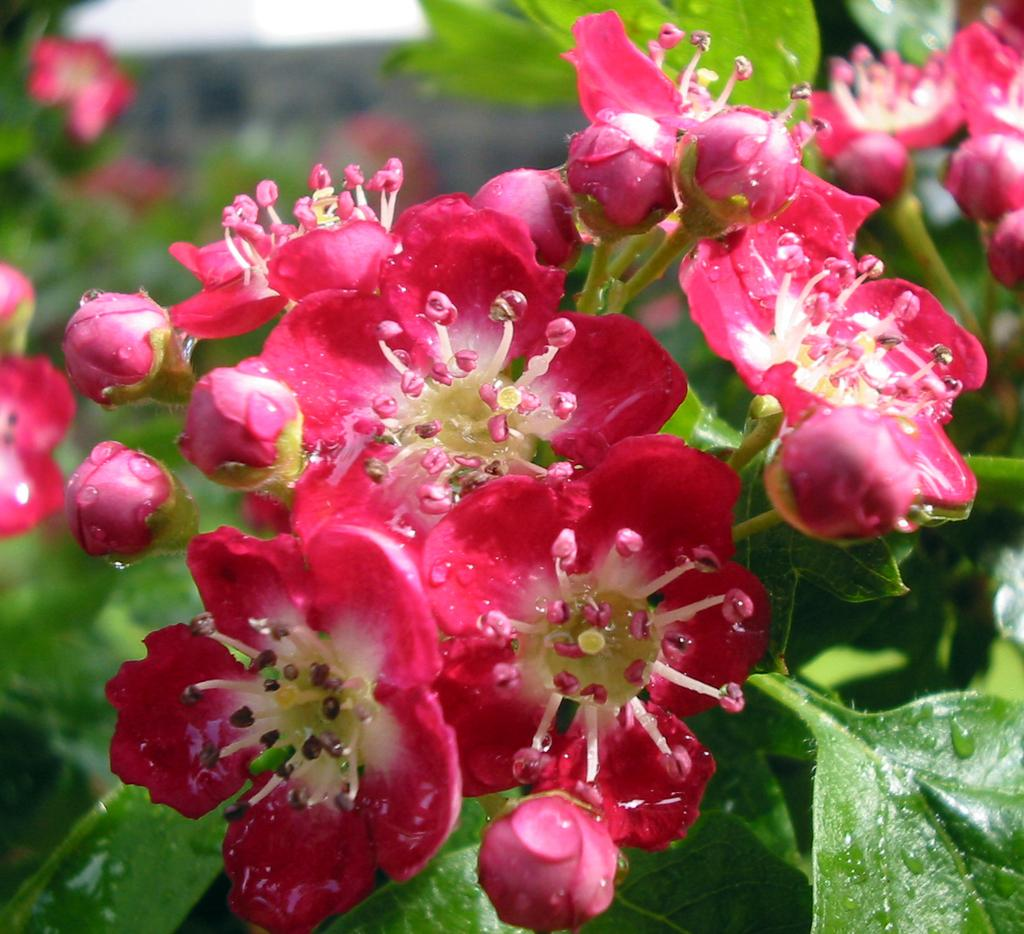What type of living organisms can be seen in the image? Plants can be seen in the image. What color are the flowers on the plants? There are pink color flowers in the image. Can you describe any other details about the plants in the image? There are water droplets visible on the plants in the image. What type of force is being applied to the train in the image? There is no train present in the image, so it is not possible to determine what type of force might be applied to it. 